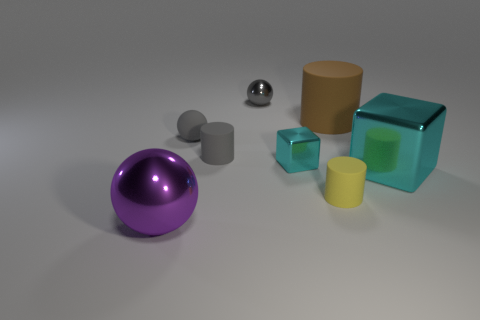Add 1 large green cylinders. How many objects exist? 9 Subtract all cubes. How many objects are left? 6 Add 2 big blocks. How many big blocks are left? 3 Add 4 tiny green matte cylinders. How many tiny green matte cylinders exist? 4 Subtract 0 blue cubes. How many objects are left? 8 Subtract all large matte cylinders. Subtract all tiny cyan shiny objects. How many objects are left? 6 